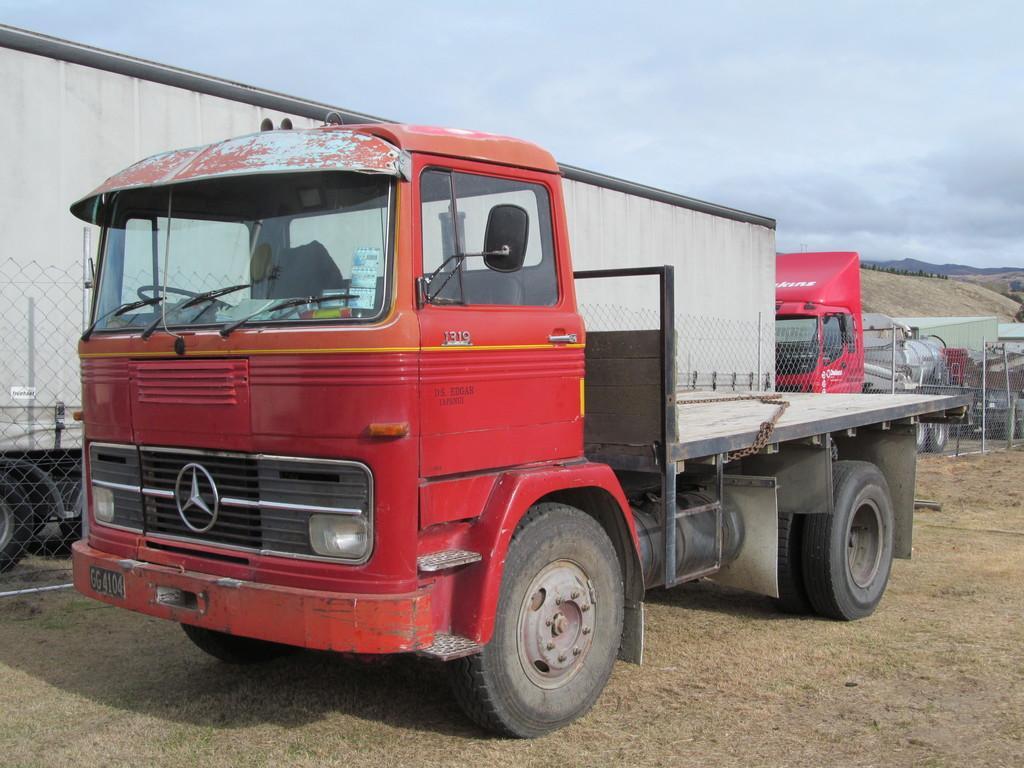Describe this image in one or two sentences. In this picture there is a vehicle in the center of the image and there are other vehicles and a net boundary in the background area of the image. 